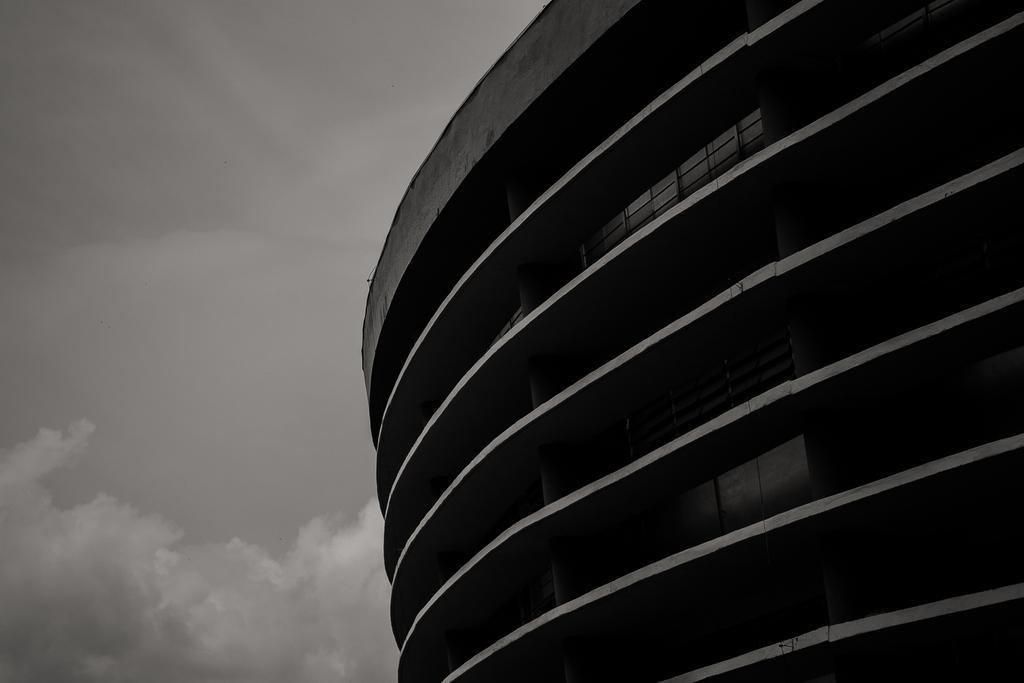In one or two sentences, can you explain what this image depicts? In this image there is a building. In the background there is the sky. 